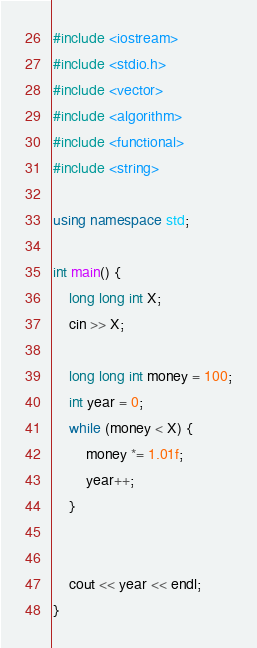<code> <loc_0><loc_0><loc_500><loc_500><_C++_>#include <iostream>
#include <stdio.h>
#include <vector> 
#include <algorithm>
#include <functional>
#include <string>

using namespace std;

int main() {
	long long int X;
	cin >> X;

	long long int money = 100;
	int year = 0;
	while (money < X) {
		money *= 1.01f;
		year++;
	}


	cout << year << endl;
}</code> 